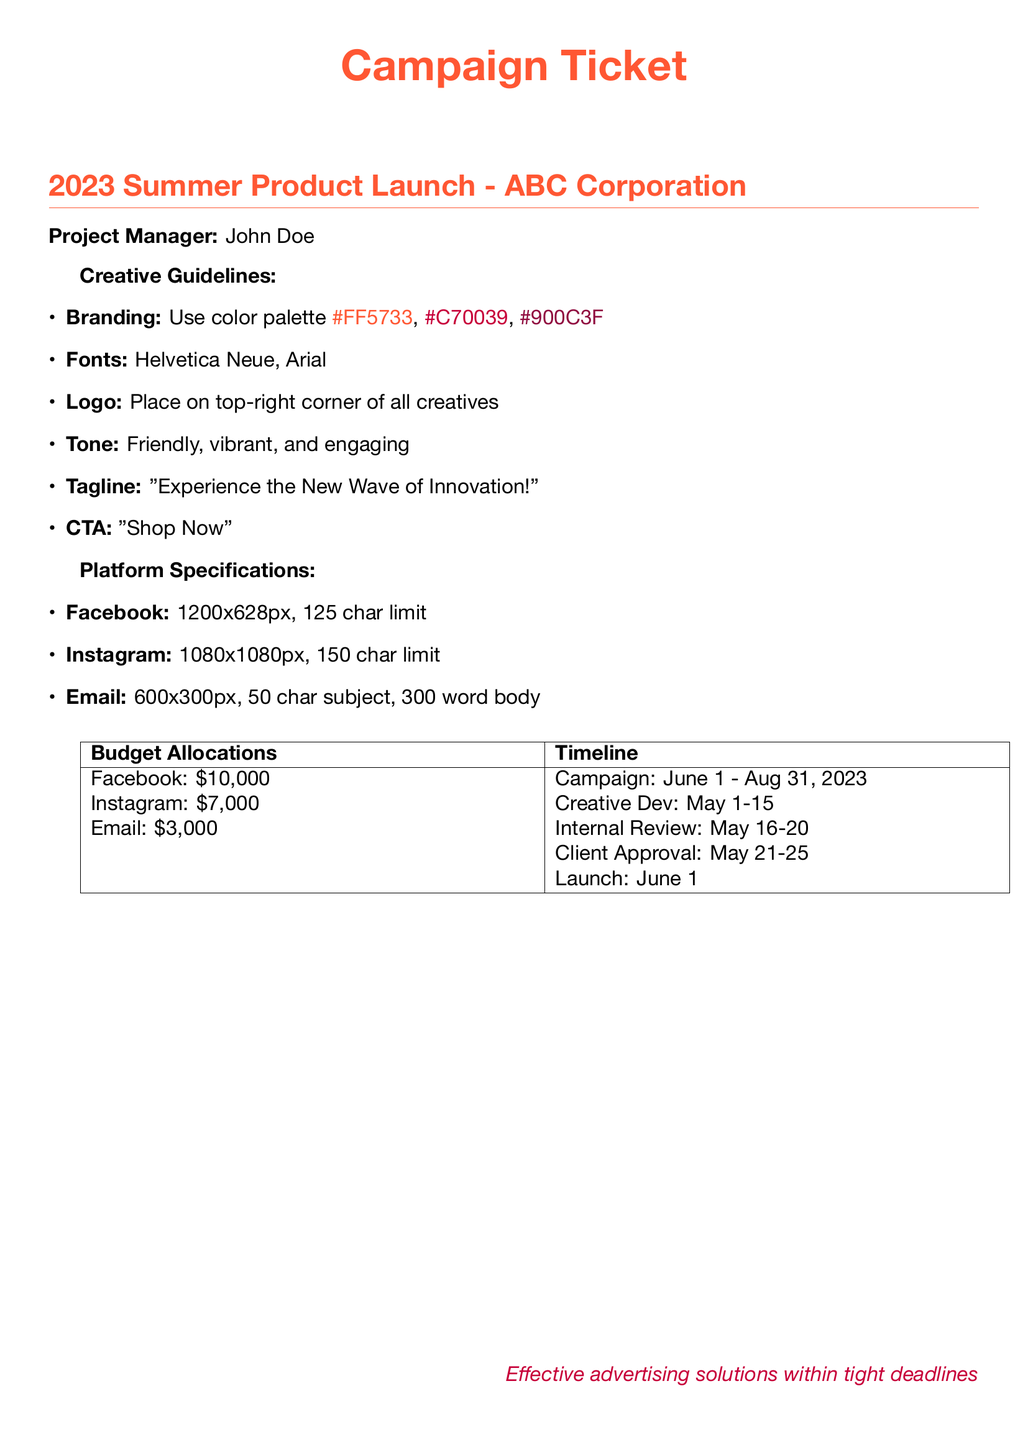What is the project manager's name? The document lists the project manager's name at the beginning, which is John Doe.
Answer: John Doe What is the campaign tagline? The tagline is specified in the creative guidelines section of the document as "Experience the New Wave of Innovation!"
Answer: "Experience the New Wave of Innovation!" What is the budget allocation for Instagram? The budget allocation for Instagram is clearly stated in the budget allocations table as $7,000.
Answer: $7,000 What is the launch date of the campaign? The launch date of the campaign can be found in the timeline section and is specified as June 1, 2023.
Answer: June 1, 2023 How many days are allocated for creative development? The creative development period is indicated in the timeline as May 1-15, which is 15 days.
Answer: 15 days What is the character limit for Facebook posts? The character limit for Facebook, as per the platform specifications, is mentioned as 125 characters.
Answer: 125 characters Which font is specified for the campaign? The document specifies the fonts to be used in the creative guidelines section, which are Helvetica Neue and Arial.
Answer: Helvetica Neue, Arial What is the total advertising budget? The total budget can be calculated from the budget allocations: Facebook ($10,000) + Instagram ($7,000) + Email ($3,000) = $20,000.
Answer: $20,000 When is the internal review scheduled? The internal review period is stated in the timeline section as May 16-20, 2023.
Answer: May 16-20, 2023 